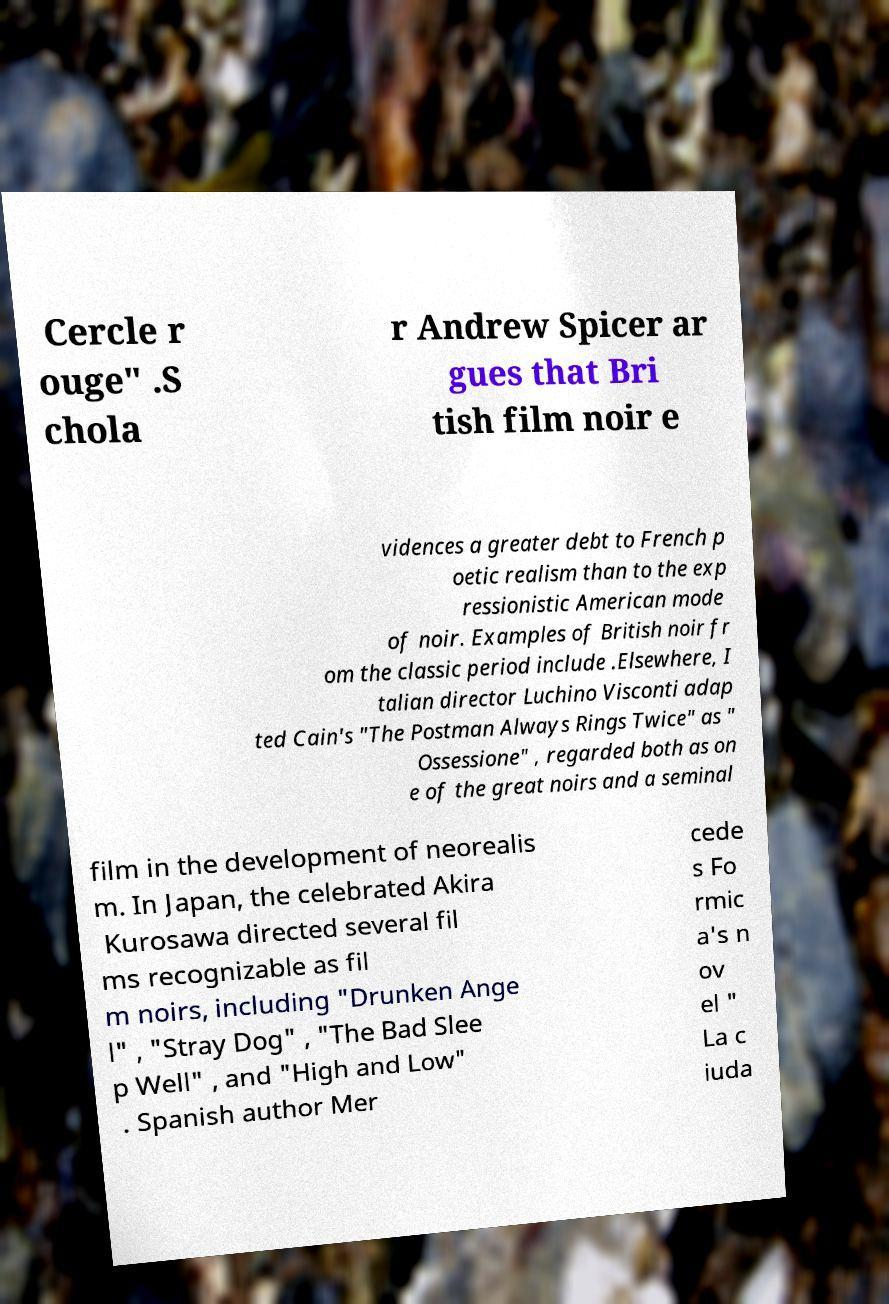There's text embedded in this image that I need extracted. Can you transcribe it verbatim? Cercle r ouge" .S chola r Andrew Spicer ar gues that Bri tish film noir e vidences a greater debt to French p oetic realism than to the exp ressionistic American mode of noir. Examples of British noir fr om the classic period include .Elsewhere, I talian director Luchino Visconti adap ted Cain's "The Postman Always Rings Twice" as " Ossessione" , regarded both as on e of the great noirs and a seminal film in the development of neorealis m. In Japan, the celebrated Akira Kurosawa directed several fil ms recognizable as fil m noirs, including "Drunken Ange l" , "Stray Dog" , "The Bad Slee p Well" , and "High and Low" . Spanish author Mer cede s Fo rmic a's n ov el " La c iuda 